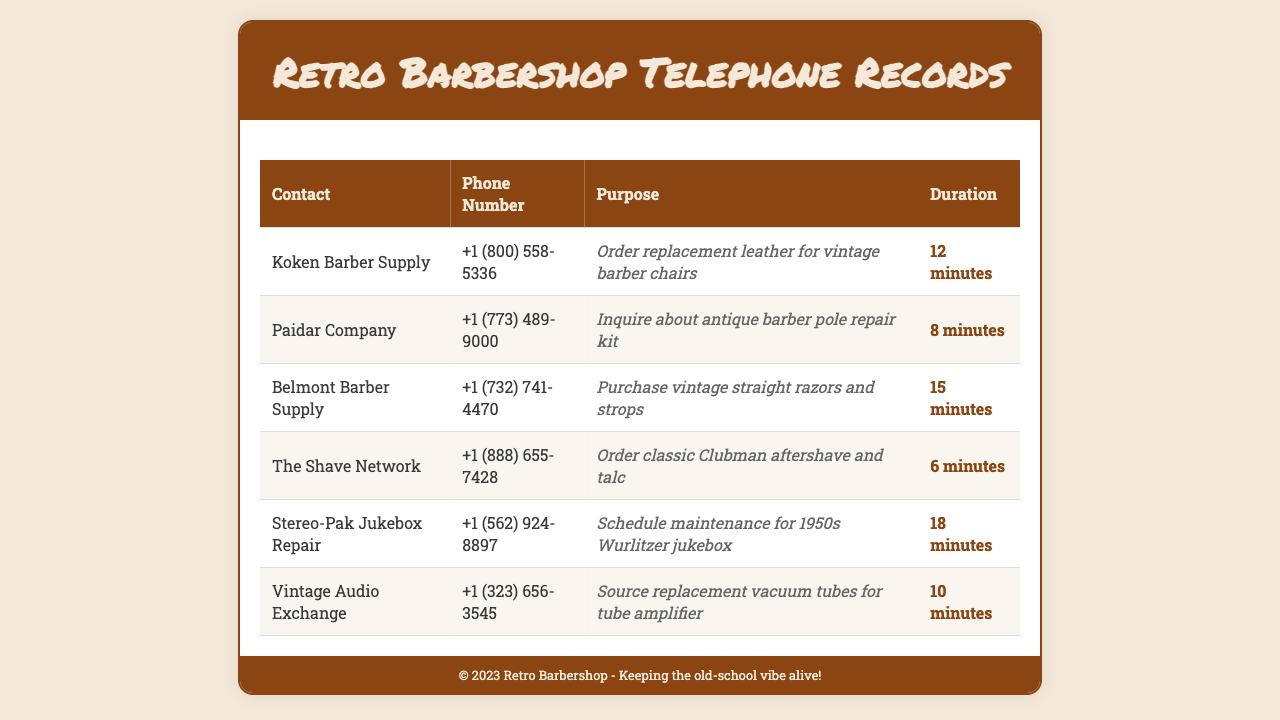What is the purpose of the call to Koken Barber Supply? The purpose is to order replacement leather for vintage barber chairs.
Answer: order replacement leather for vintage barber chairs What is the phone number for Paidar Company? The phone number listed for Paidar Company is +1 (773) 489-9000.
Answer: +1 (773) 489-9000 How long did the call to Belmont Barber Supply last? The duration of the call was 15 minutes.
Answer: 15 minutes Which supplier was contacted to schedule maintenance for a jukebox? Stereo-Pak Jukebox Repair was contacted for maintenance scheduling.
Answer: Stereo-Pak Jukebox Repair What item was ordered from The Shave Network? Classic Clubman aftershave and talc were ordered.
Answer: classic Clubman aftershave and talc How many minutes was the call to Vintage Audio Exchange? The call lasted 10 minutes.
Answer: 10 minutes What type of product did the call to Paidar Company inquire about? The inquiry was about an antique barber pole repair kit.
Answer: antique barber pole repair kit List all suppliers contacted for barbershop maintenance. The suppliers are Koken Barber Supply, Paidar Company, Belmont Barber Supply, The Shave Network, Stereo-Pak Jukebox Repair, and Vintage Audio Exchange.
Answer: Koken Barber Supply, Paidar Company, Belmont Barber Supply, The Shave Network, Stereo-Pak Jukebox Repair, Vintage Audio Exchange What is the primary purpose of these telephone records? The records document outgoing calls related to barbershop maintenance and supplies.
Answer: outgoing calls related to barbershop maintenance and supplies 